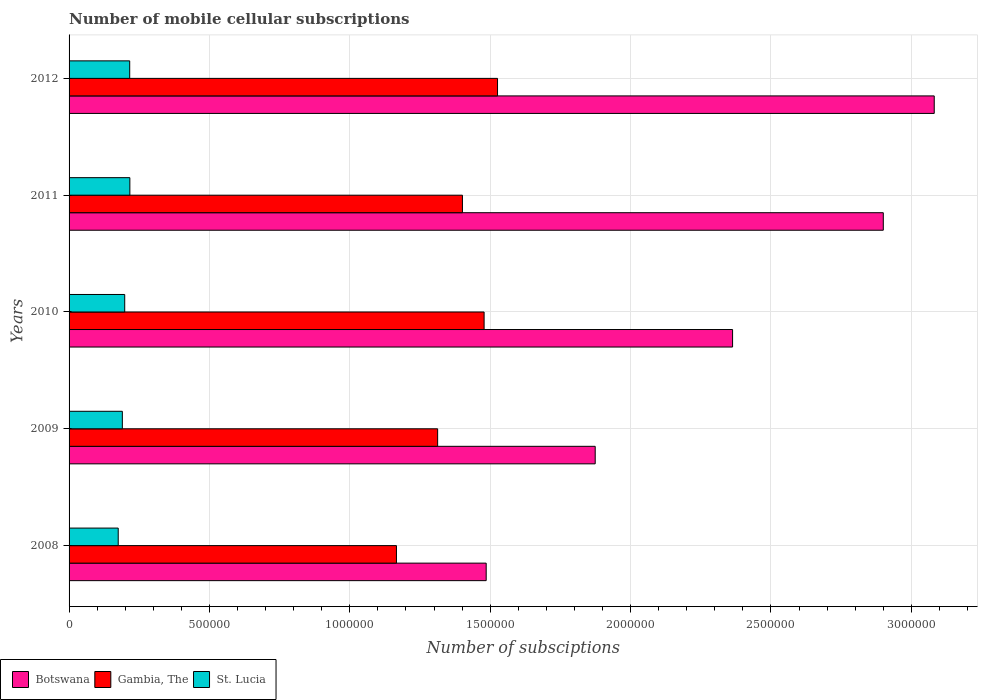How many groups of bars are there?
Offer a terse response. 5. Are the number of bars per tick equal to the number of legend labels?
Offer a terse response. Yes. How many bars are there on the 3rd tick from the bottom?
Keep it short and to the point. 3. What is the label of the 4th group of bars from the top?
Your answer should be very brief. 2009. What is the number of mobile cellular subscriptions in St. Lucia in 2009?
Provide a succinct answer. 1.90e+05. Across all years, what is the maximum number of mobile cellular subscriptions in Gambia, The?
Give a very brief answer. 1.53e+06. Across all years, what is the minimum number of mobile cellular subscriptions in Botswana?
Your answer should be very brief. 1.49e+06. In which year was the number of mobile cellular subscriptions in Botswana minimum?
Provide a short and direct response. 2008. What is the total number of mobile cellular subscriptions in Botswana in the graph?
Provide a succinct answer. 1.17e+07. What is the difference between the number of mobile cellular subscriptions in Gambia, The in 2009 and that in 2011?
Make the answer very short. -8.83e+04. What is the difference between the number of mobile cellular subscriptions in Botswana in 2011 and the number of mobile cellular subscriptions in St. Lucia in 2012?
Provide a short and direct response. 2.68e+06. What is the average number of mobile cellular subscriptions in Gambia, The per year?
Make the answer very short. 1.38e+06. In the year 2010, what is the difference between the number of mobile cellular subscriptions in Botswana and number of mobile cellular subscriptions in Gambia, The?
Offer a very short reply. 8.85e+05. What is the ratio of the number of mobile cellular subscriptions in St. Lucia in 2010 to that in 2012?
Your answer should be very brief. 0.92. Is the number of mobile cellular subscriptions in St. Lucia in 2009 less than that in 2012?
Your response must be concise. Yes. What is the difference between the highest and the second highest number of mobile cellular subscriptions in Gambia, The?
Your answer should be compact. 4.78e+04. What is the difference between the highest and the lowest number of mobile cellular subscriptions in Gambia, The?
Offer a terse response. 3.60e+05. In how many years, is the number of mobile cellular subscriptions in Gambia, The greater than the average number of mobile cellular subscriptions in Gambia, The taken over all years?
Make the answer very short. 3. Is the sum of the number of mobile cellular subscriptions in Gambia, The in 2011 and 2012 greater than the maximum number of mobile cellular subscriptions in Botswana across all years?
Provide a short and direct response. No. What does the 2nd bar from the top in 2009 represents?
Provide a succinct answer. Gambia, The. What does the 1st bar from the bottom in 2011 represents?
Your answer should be very brief. Botswana. How many years are there in the graph?
Give a very brief answer. 5. Does the graph contain any zero values?
Offer a very short reply. No. Does the graph contain grids?
Offer a very short reply. Yes. Where does the legend appear in the graph?
Provide a succinct answer. Bottom left. How many legend labels are there?
Your response must be concise. 3. How are the legend labels stacked?
Give a very brief answer. Horizontal. What is the title of the graph?
Offer a very short reply. Number of mobile cellular subscriptions. Does "Italy" appear as one of the legend labels in the graph?
Make the answer very short. No. What is the label or title of the X-axis?
Keep it short and to the point. Number of subsciptions. What is the label or title of the Y-axis?
Provide a short and direct response. Years. What is the Number of subsciptions in Botswana in 2008?
Ensure brevity in your answer.  1.49e+06. What is the Number of subsciptions of Gambia, The in 2008?
Provide a short and direct response. 1.17e+06. What is the Number of subsciptions of St. Lucia in 2008?
Offer a very short reply. 1.75e+05. What is the Number of subsciptions in Botswana in 2009?
Keep it short and to the point. 1.87e+06. What is the Number of subsciptions of Gambia, The in 2009?
Your answer should be very brief. 1.31e+06. What is the Number of subsciptions of St. Lucia in 2009?
Keep it short and to the point. 1.90e+05. What is the Number of subsciptions in Botswana in 2010?
Make the answer very short. 2.36e+06. What is the Number of subsciptions of Gambia, The in 2010?
Make the answer very short. 1.48e+06. What is the Number of subsciptions in St. Lucia in 2010?
Ensure brevity in your answer.  1.98e+05. What is the Number of subsciptions of Botswana in 2011?
Keep it short and to the point. 2.90e+06. What is the Number of subsciptions in Gambia, The in 2011?
Ensure brevity in your answer.  1.40e+06. What is the Number of subsciptions in St. Lucia in 2011?
Ensure brevity in your answer.  2.17e+05. What is the Number of subsciptions in Botswana in 2012?
Provide a succinct answer. 3.08e+06. What is the Number of subsciptions in Gambia, The in 2012?
Provide a succinct answer. 1.53e+06. What is the Number of subsciptions of St. Lucia in 2012?
Provide a short and direct response. 2.16e+05. Across all years, what is the maximum Number of subsciptions of Botswana?
Your response must be concise. 3.08e+06. Across all years, what is the maximum Number of subsciptions of Gambia, The?
Provide a short and direct response. 1.53e+06. Across all years, what is the maximum Number of subsciptions in St. Lucia?
Your response must be concise. 2.17e+05. Across all years, what is the minimum Number of subsciptions in Botswana?
Your answer should be very brief. 1.49e+06. Across all years, what is the minimum Number of subsciptions of Gambia, The?
Your answer should be compact. 1.17e+06. Across all years, what is the minimum Number of subsciptions of St. Lucia?
Your response must be concise. 1.75e+05. What is the total Number of subsciptions of Botswana in the graph?
Give a very brief answer. 1.17e+07. What is the total Number of subsciptions in Gambia, The in the graph?
Provide a succinct answer. 6.88e+06. What is the total Number of subsciptions in St. Lucia in the graph?
Your answer should be compact. 9.96e+05. What is the difference between the Number of subsciptions of Botswana in 2008 and that in 2009?
Provide a short and direct response. -3.88e+05. What is the difference between the Number of subsciptions of Gambia, The in 2008 and that in 2009?
Offer a very short reply. -1.47e+05. What is the difference between the Number of subsciptions in St. Lucia in 2008 and that in 2009?
Keep it short and to the point. -1.47e+04. What is the difference between the Number of subsciptions of Botswana in 2008 and that in 2010?
Ensure brevity in your answer.  -8.78e+05. What is the difference between the Number of subsciptions in Gambia, The in 2008 and that in 2010?
Provide a succinct answer. -3.12e+05. What is the difference between the Number of subsciptions in St. Lucia in 2008 and that in 2010?
Your answer should be very brief. -2.32e+04. What is the difference between the Number of subsciptions of Botswana in 2008 and that in 2011?
Your response must be concise. -1.41e+06. What is the difference between the Number of subsciptions in Gambia, The in 2008 and that in 2011?
Your answer should be compact. -2.35e+05. What is the difference between the Number of subsciptions in St. Lucia in 2008 and that in 2011?
Your answer should be very brief. -4.15e+04. What is the difference between the Number of subsciptions of Botswana in 2008 and that in 2012?
Provide a short and direct response. -1.60e+06. What is the difference between the Number of subsciptions of Gambia, The in 2008 and that in 2012?
Make the answer very short. -3.60e+05. What is the difference between the Number of subsciptions in St. Lucia in 2008 and that in 2012?
Provide a succinct answer. -4.10e+04. What is the difference between the Number of subsciptions in Botswana in 2009 and that in 2010?
Your answer should be compact. -4.89e+05. What is the difference between the Number of subsciptions in Gambia, The in 2009 and that in 2010?
Provide a short and direct response. -1.65e+05. What is the difference between the Number of subsciptions of St. Lucia in 2009 and that in 2010?
Offer a very short reply. -8474. What is the difference between the Number of subsciptions in Botswana in 2009 and that in 2011?
Your answer should be compact. -1.03e+06. What is the difference between the Number of subsciptions of Gambia, The in 2009 and that in 2011?
Make the answer very short. -8.83e+04. What is the difference between the Number of subsciptions in St. Lucia in 2009 and that in 2011?
Provide a short and direct response. -2.68e+04. What is the difference between the Number of subsciptions of Botswana in 2009 and that in 2012?
Offer a very short reply. -1.21e+06. What is the difference between the Number of subsciptions of Gambia, The in 2009 and that in 2012?
Ensure brevity in your answer.  -2.13e+05. What is the difference between the Number of subsciptions of St. Lucia in 2009 and that in 2012?
Keep it short and to the point. -2.63e+04. What is the difference between the Number of subsciptions in Botswana in 2010 and that in 2011?
Your answer should be compact. -5.37e+05. What is the difference between the Number of subsciptions of Gambia, The in 2010 and that in 2011?
Offer a terse response. 7.72e+04. What is the difference between the Number of subsciptions in St. Lucia in 2010 and that in 2011?
Your answer should be very brief. -1.83e+04. What is the difference between the Number of subsciptions of Botswana in 2010 and that in 2012?
Provide a succinct answer. -7.18e+05. What is the difference between the Number of subsciptions of Gambia, The in 2010 and that in 2012?
Your answer should be very brief. -4.78e+04. What is the difference between the Number of subsciptions in St. Lucia in 2010 and that in 2012?
Provide a short and direct response. -1.78e+04. What is the difference between the Number of subsciptions of Botswana in 2011 and that in 2012?
Your answer should be compact. -1.81e+05. What is the difference between the Number of subsciptions in Gambia, The in 2011 and that in 2012?
Provide a succinct answer. -1.25e+05. What is the difference between the Number of subsciptions of St. Lucia in 2011 and that in 2012?
Give a very brief answer. 530. What is the difference between the Number of subsciptions in Botswana in 2008 and the Number of subsciptions in Gambia, The in 2009?
Give a very brief answer. 1.73e+05. What is the difference between the Number of subsciptions in Botswana in 2008 and the Number of subsciptions in St. Lucia in 2009?
Your response must be concise. 1.30e+06. What is the difference between the Number of subsciptions of Gambia, The in 2008 and the Number of subsciptions of St. Lucia in 2009?
Make the answer very short. 9.76e+05. What is the difference between the Number of subsciptions of Botswana in 2008 and the Number of subsciptions of Gambia, The in 2010?
Ensure brevity in your answer.  7444. What is the difference between the Number of subsciptions of Botswana in 2008 and the Number of subsciptions of St. Lucia in 2010?
Offer a very short reply. 1.29e+06. What is the difference between the Number of subsciptions in Gambia, The in 2008 and the Number of subsciptions in St. Lucia in 2010?
Keep it short and to the point. 9.68e+05. What is the difference between the Number of subsciptions in Botswana in 2008 and the Number of subsciptions in Gambia, The in 2011?
Offer a terse response. 8.46e+04. What is the difference between the Number of subsciptions in Botswana in 2008 and the Number of subsciptions in St. Lucia in 2011?
Your answer should be compact. 1.27e+06. What is the difference between the Number of subsciptions in Gambia, The in 2008 and the Number of subsciptions in St. Lucia in 2011?
Make the answer very short. 9.50e+05. What is the difference between the Number of subsciptions of Botswana in 2008 and the Number of subsciptions of Gambia, The in 2012?
Provide a short and direct response. -4.04e+04. What is the difference between the Number of subsciptions of Botswana in 2008 and the Number of subsciptions of St. Lucia in 2012?
Provide a short and direct response. 1.27e+06. What is the difference between the Number of subsciptions of Gambia, The in 2008 and the Number of subsciptions of St. Lucia in 2012?
Your answer should be compact. 9.50e+05. What is the difference between the Number of subsciptions of Botswana in 2009 and the Number of subsciptions of Gambia, The in 2010?
Your answer should be compact. 3.96e+05. What is the difference between the Number of subsciptions of Botswana in 2009 and the Number of subsciptions of St. Lucia in 2010?
Make the answer very short. 1.68e+06. What is the difference between the Number of subsciptions in Gambia, The in 2009 and the Number of subsciptions in St. Lucia in 2010?
Your answer should be compact. 1.11e+06. What is the difference between the Number of subsciptions of Botswana in 2009 and the Number of subsciptions of Gambia, The in 2011?
Your answer should be very brief. 4.73e+05. What is the difference between the Number of subsciptions of Botswana in 2009 and the Number of subsciptions of St. Lucia in 2011?
Keep it short and to the point. 1.66e+06. What is the difference between the Number of subsciptions in Gambia, The in 2009 and the Number of subsciptions in St. Lucia in 2011?
Provide a succinct answer. 1.10e+06. What is the difference between the Number of subsciptions of Botswana in 2009 and the Number of subsciptions of Gambia, The in 2012?
Provide a short and direct response. 3.48e+05. What is the difference between the Number of subsciptions in Botswana in 2009 and the Number of subsciptions in St. Lucia in 2012?
Your answer should be compact. 1.66e+06. What is the difference between the Number of subsciptions of Gambia, The in 2009 and the Number of subsciptions of St. Lucia in 2012?
Provide a short and direct response. 1.10e+06. What is the difference between the Number of subsciptions of Botswana in 2010 and the Number of subsciptions of Gambia, The in 2011?
Your answer should be very brief. 9.62e+05. What is the difference between the Number of subsciptions of Botswana in 2010 and the Number of subsciptions of St. Lucia in 2011?
Provide a short and direct response. 2.15e+06. What is the difference between the Number of subsciptions of Gambia, The in 2010 and the Number of subsciptions of St. Lucia in 2011?
Provide a short and direct response. 1.26e+06. What is the difference between the Number of subsciptions of Botswana in 2010 and the Number of subsciptions of Gambia, The in 2012?
Offer a very short reply. 8.37e+05. What is the difference between the Number of subsciptions in Botswana in 2010 and the Number of subsciptions in St. Lucia in 2012?
Offer a terse response. 2.15e+06. What is the difference between the Number of subsciptions of Gambia, The in 2010 and the Number of subsciptions of St. Lucia in 2012?
Your answer should be compact. 1.26e+06. What is the difference between the Number of subsciptions in Botswana in 2011 and the Number of subsciptions in Gambia, The in 2012?
Offer a terse response. 1.37e+06. What is the difference between the Number of subsciptions in Botswana in 2011 and the Number of subsciptions in St. Lucia in 2012?
Make the answer very short. 2.68e+06. What is the difference between the Number of subsciptions of Gambia, The in 2011 and the Number of subsciptions of St. Lucia in 2012?
Give a very brief answer. 1.19e+06. What is the average Number of subsciptions in Botswana per year?
Provide a succinct answer. 2.34e+06. What is the average Number of subsciptions in Gambia, The per year?
Keep it short and to the point. 1.38e+06. What is the average Number of subsciptions of St. Lucia per year?
Your answer should be very brief. 1.99e+05. In the year 2008, what is the difference between the Number of subsciptions of Botswana and Number of subsciptions of Gambia, The?
Your response must be concise. 3.20e+05. In the year 2008, what is the difference between the Number of subsciptions in Botswana and Number of subsciptions in St. Lucia?
Offer a terse response. 1.31e+06. In the year 2008, what is the difference between the Number of subsciptions in Gambia, The and Number of subsciptions in St. Lucia?
Provide a short and direct response. 9.91e+05. In the year 2009, what is the difference between the Number of subsciptions in Botswana and Number of subsciptions in Gambia, The?
Your answer should be very brief. 5.61e+05. In the year 2009, what is the difference between the Number of subsciptions in Botswana and Number of subsciptions in St. Lucia?
Your answer should be very brief. 1.68e+06. In the year 2009, what is the difference between the Number of subsciptions of Gambia, The and Number of subsciptions of St. Lucia?
Offer a very short reply. 1.12e+06. In the year 2010, what is the difference between the Number of subsciptions of Botswana and Number of subsciptions of Gambia, The?
Your answer should be very brief. 8.85e+05. In the year 2010, what is the difference between the Number of subsciptions in Botswana and Number of subsciptions in St. Lucia?
Your answer should be very brief. 2.17e+06. In the year 2010, what is the difference between the Number of subsciptions in Gambia, The and Number of subsciptions in St. Lucia?
Give a very brief answer. 1.28e+06. In the year 2011, what is the difference between the Number of subsciptions in Botswana and Number of subsciptions in Gambia, The?
Your answer should be very brief. 1.50e+06. In the year 2011, what is the difference between the Number of subsciptions in Botswana and Number of subsciptions in St. Lucia?
Offer a very short reply. 2.68e+06. In the year 2011, what is the difference between the Number of subsciptions of Gambia, The and Number of subsciptions of St. Lucia?
Provide a succinct answer. 1.18e+06. In the year 2012, what is the difference between the Number of subsciptions in Botswana and Number of subsciptions in Gambia, The?
Offer a very short reply. 1.56e+06. In the year 2012, what is the difference between the Number of subsciptions in Botswana and Number of subsciptions in St. Lucia?
Ensure brevity in your answer.  2.87e+06. In the year 2012, what is the difference between the Number of subsciptions in Gambia, The and Number of subsciptions in St. Lucia?
Offer a terse response. 1.31e+06. What is the ratio of the Number of subsciptions of Botswana in 2008 to that in 2009?
Keep it short and to the point. 0.79. What is the ratio of the Number of subsciptions of Gambia, The in 2008 to that in 2009?
Offer a terse response. 0.89. What is the ratio of the Number of subsciptions in St. Lucia in 2008 to that in 2009?
Keep it short and to the point. 0.92. What is the ratio of the Number of subsciptions of Botswana in 2008 to that in 2010?
Provide a succinct answer. 0.63. What is the ratio of the Number of subsciptions of Gambia, The in 2008 to that in 2010?
Your response must be concise. 0.79. What is the ratio of the Number of subsciptions of St. Lucia in 2008 to that in 2010?
Your answer should be compact. 0.88. What is the ratio of the Number of subsciptions in Botswana in 2008 to that in 2011?
Your answer should be very brief. 0.51. What is the ratio of the Number of subsciptions in Gambia, The in 2008 to that in 2011?
Your response must be concise. 0.83. What is the ratio of the Number of subsciptions in St. Lucia in 2008 to that in 2011?
Provide a succinct answer. 0.81. What is the ratio of the Number of subsciptions in Botswana in 2008 to that in 2012?
Your answer should be very brief. 0.48. What is the ratio of the Number of subsciptions in Gambia, The in 2008 to that in 2012?
Provide a succinct answer. 0.76. What is the ratio of the Number of subsciptions of St. Lucia in 2008 to that in 2012?
Your answer should be compact. 0.81. What is the ratio of the Number of subsciptions in Botswana in 2009 to that in 2010?
Offer a very short reply. 0.79. What is the ratio of the Number of subsciptions of Gambia, The in 2009 to that in 2010?
Provide a short and direct response. 0.89. What is the ratio of the Number of subsciptions of St. Lucia in 2009 to that in 2010?
Ensure brevity in your answer.  0.96. What is the ratio of the Number of subsciptions in Botswana in 2009 to that in 2011?
Offer a very short reply. 0.65. What is the ratio of the Number of subsciptions of Gambia, The in 2009 to that in 2011?
Keep it short and to the point. 0.94. What is the ratio of the Number of subsciptions in St. Lucia in 2009 to that in 2011?
Your response must be concise. 0.88. What is the ratio of the Number of subsciptions of Botswana in 2009 to that in 2012?
Ensure brevity in your answer.  0.61. What is the ratio of the Number of subsciptions in Gambia, The in 2009 to that in 2012?
Provide a short and direct response. 0.86. What is the ratio of the Number of subsciptions in St. Lucia in 2009 to that in 2012?
Offer a very short reply. 0.88. What is the ratio of the Number of subsciptions in Botswana in 2010 to that in 2011?
Your answer should be very brief. 0.81. What is the ratio of the Number of subsciptions in Gambia, The in 2010 to that in 2011?
Your answer should be very brief. 1.06. What is the ratio of the Number of subsciptions of St. Lucia in 2010 to that in 2011?
Provide a short and direct response. 0.92. What is the ratio of the Number of subsciptions of Botswana in 2010 to that in 2012?
Give a very brief answer. 0.77. What is the ratio of the Number of subsciptions in Gambia, The in 2010 to that in 2012?
Provide a short and direct response. 0.97. What is the ratio of the Number of subsciptions in St. Lucia in 2010 to that in 2012?
Offer a very short reply. 0.92. What is the ratio of the Number of subsciptions of Botswana in 2011 to that in 2012?
Keep it short and to the point. 0.94. What is the ratio of the Number of subsciptions in Gambia, The in 2011 to that in 2012?
Make the answer very short. 0.92. What is the difference between the highest and the second highest Number of subsciptions of Botswana?
Ensure brevity in your answer.  1.81e+05. What is the difference between the highest and the second highest Number of subsciptions in Gambia, The?
Make the answer very short. 4.78e+04. What is the difference between the highest and the second highest Number of subsciptions in St. Lucia?
Provide a short and direct response. 530. What is the difference between the highest and the lowest Number of subsciptions of Botswana?
Offer a terse response. 1.60e+06. What is the difference between the highest and the lowest Number of subsciptions in Gambia, The?
Your answer should be compact. 3.60e+05. What is the difference between the highest and the lowest Number of subsciptions of St. Lucia?
Ensure brevity in your answer.  4.15e+04. 